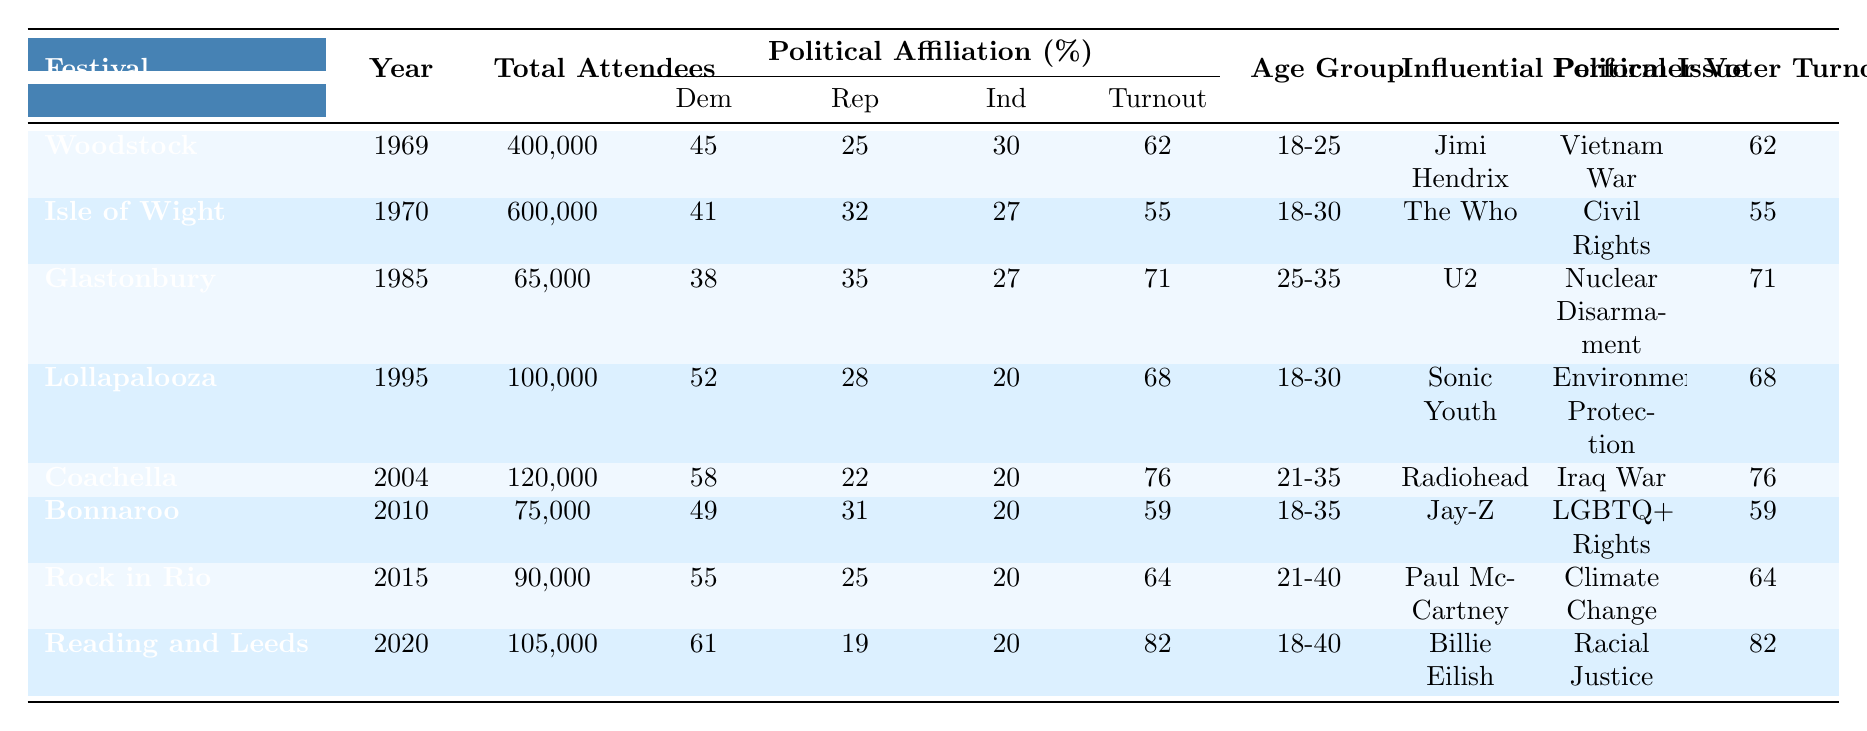What was the Voter Turnout Percentage at Woodstock in 1969? The table states that the Voter Turnout Percentage for Woodstock in 1969 is 62%.
Answer: 62% Which festival had the highest Voter Turnout Percentage? By comparing the Voter Turnout Percentages in the table, Reading and Leeds Festival in 2020 had the highest at 82%.
Answer: 82% What was the Republican Percentage among attendees at the Coachella festival in 2004? According to the table, the Republican Percentage at Coachella in 2004 was 22%.
Answer: 22% Which festival had the lowest Total Attendees and what was its Voter Turnout Percentage? The festival with the lowest Total Attendees is Glastonbury in 1985, which had 65,000 attendees and a Voter Turnout Percentage of 71%.
Answer: 71%, 65000 Were more festival attendees likely to identify as Democrats or Independents at the Isle of Wight Festival in 1970? The table shows 41% of attendees at the Isle of Wight Festival identified as Democrats and 27% as Independents. Since 41% > 27%, more attendees identified as Democrats.
Answer: Yes What is the difference in Voter Turnout Percentage between the Glastonbury Festival in 1985 and Bonnaroo in 2010? The Voter Turnout Percentage for Glastonbury in 1985 is 71%, and for Bonnaroo in 2010 is 59%. The difference is 71% - 59% = 12%.
Answer: 12% Which political issue of concern is associated with Rock in Rio in 2015? The table indicates that Rock in Rio in 2015 was associated with the political issue of Climate Change.
Answer: Climate Change What can we conclude about the trend in Voter Turnout Percentage from the 1960s to the 2020s based on the table? The Voter Turnout Percentages are generally increasing over the decades: 62% (1969), 55% (1970), 71% (1985), 68% (1995), 76% (2004), 59% (2010), 64% (2015), and 82% (2020). The highest recorded is in 2020.
Answer: Increasing trend Which age group was predominant at the Lollapalooza festival in 1995? The table states that the predominant age group at Lollapalooza in 1995 was 18-30.
Answer: 18-30 Has the Republican Percentage among festival attendees decreased from Woodstock to Reading and Leeds? Yes, the Republican Percentage decreased from 25% at Woodstock (1969) to 19% at Reading and Leeds (2020).
Answer: Yes Calculate the average Republican Percentage among the festivals listed. The Republican Percentages are 25, 32, 35, 28, 22, 31, 25, and 19. The sum is 25+32+35+28+22+31+25+19 =  227, and there are 8 data points, so the average is 227/8 = 28.375.
Answer: 28.375 